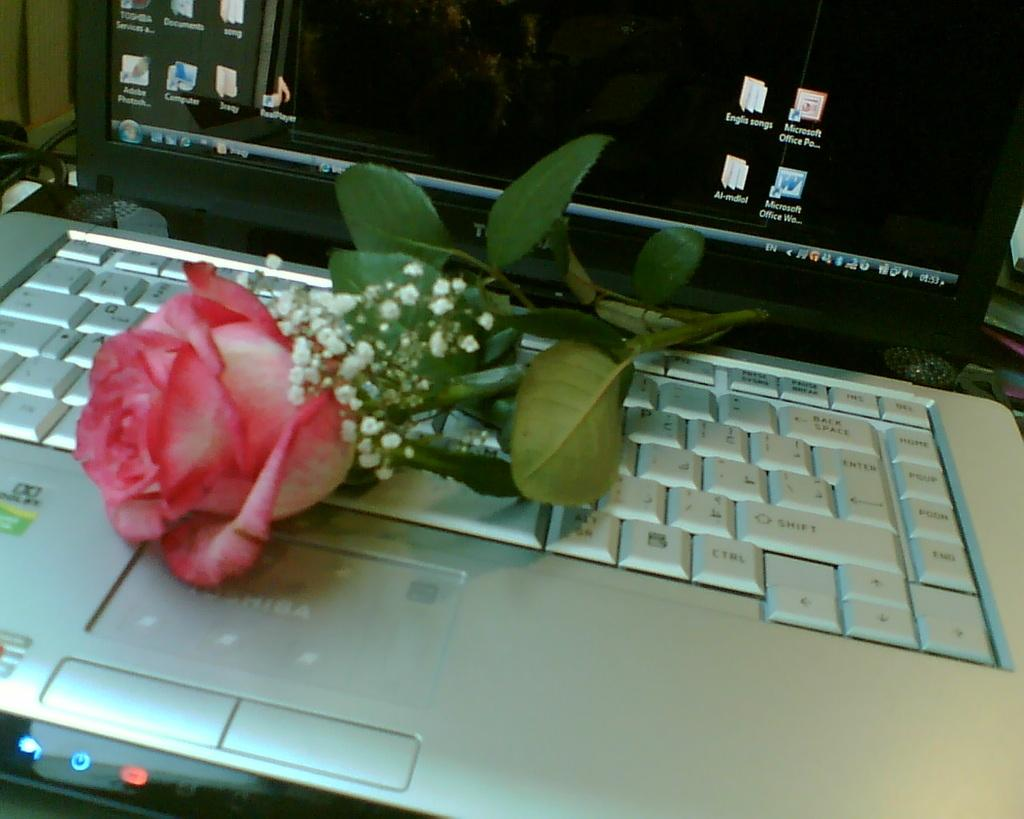What electronic device is visible in the image? There is a laptop in the image. What is the state of the laptop in the image? The laptop is opened. What decorative item is placed on the laptop's keyboard? There is a rose flower with leaves on the keyboard. What can be seen in the background of the image? There are wires visible in the background of the image. How many kittens are playing with the screw in the image? There are no kittens or screws present in the image. What message of hope can be read from the laptop screen in the image? The image does not show any text or message on the laptop screen, so it cannot be determined if there is a message of hope. 